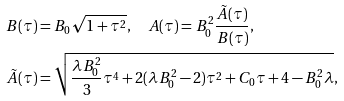<formula> <loc_0><loc_0><loc_500><loc_500>B ( \tau ) & = B _ { 0 } \sqrt { 1 + \tau ^ { 2 } } , \quad A ( \tau ) = B _ { 0 } ^ { 2 } \frac { \tilde { A } ( \tau ) } { B ( \tau ) } , \\ \tilde { A } ( \tau ) & = \sqrt { \frac { \lambda B _ { 0 } ^ { 2 } } 3 \tau ^ { 4 } + 2 ( \lambda B _ { 0 } ^ { 2 } - 2 ) \tau ^ { 2 } + C _ { 0 } \tau + 4 - B _ { 0 } ^ { 2 } \lambda } ,</formula> 